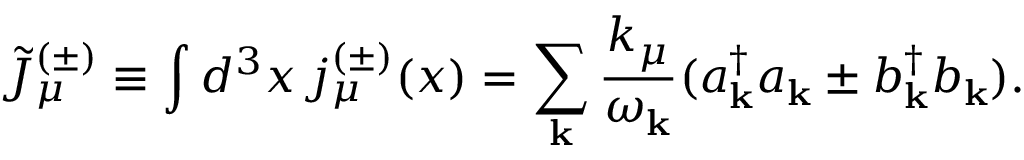Convert formula to latex. <formula><loc_0><loc_0><loc_500><loc_500>\tilde { J } _ { \mu } ^ { ( \pm ) } \equiv \int d ^ { 3 } x \, j _ { \mu } ^ { ( \pm ) } ( x ) = \sum _ { k } \frac { k _ { \mu } } { \omega _ { k } } ( a _ { k } ^ { \dagger } a _ { k } \pm b _ { k } ^ { \dagger } b _ { k } ) .</formula> 